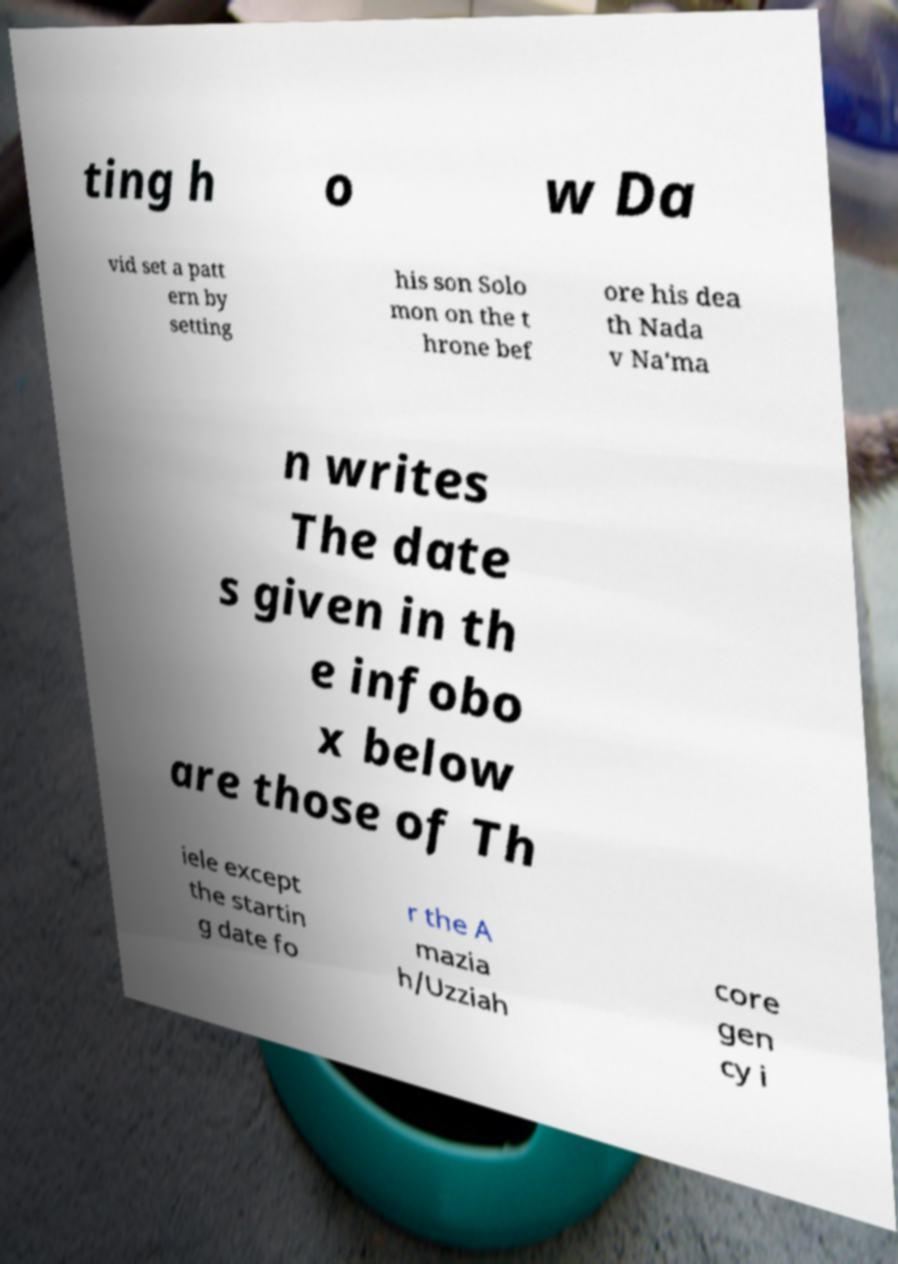Can you accurately transcribe the text from the provided image for me? ting h o w Da vid set a patt ern by setting his son Solo mon on the t hrone bef ore his dea th Nada v Na'ma n writes The date s given in th e infobo x below are those of Th iele except the startin g date fo r the A mazia h/Uzziah core gen cy i 